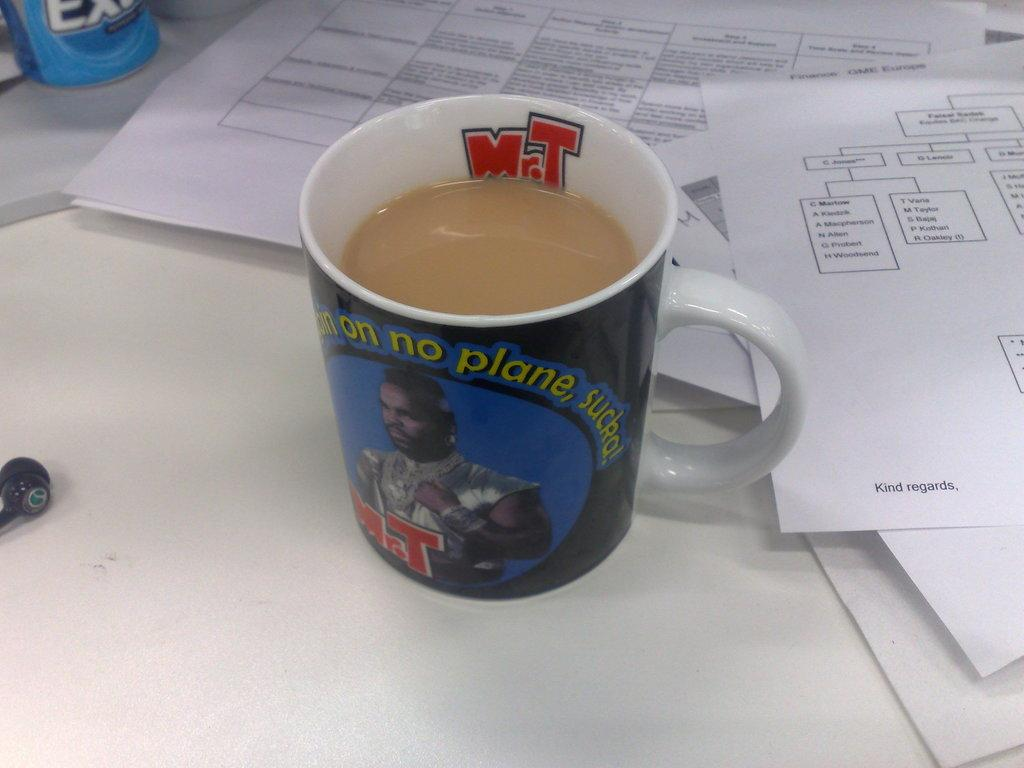<image>
Offer a succinct explanation of the picture presented. desktop with papers and a Mr. T mug mug with phrase about not getting on no plane sucker 